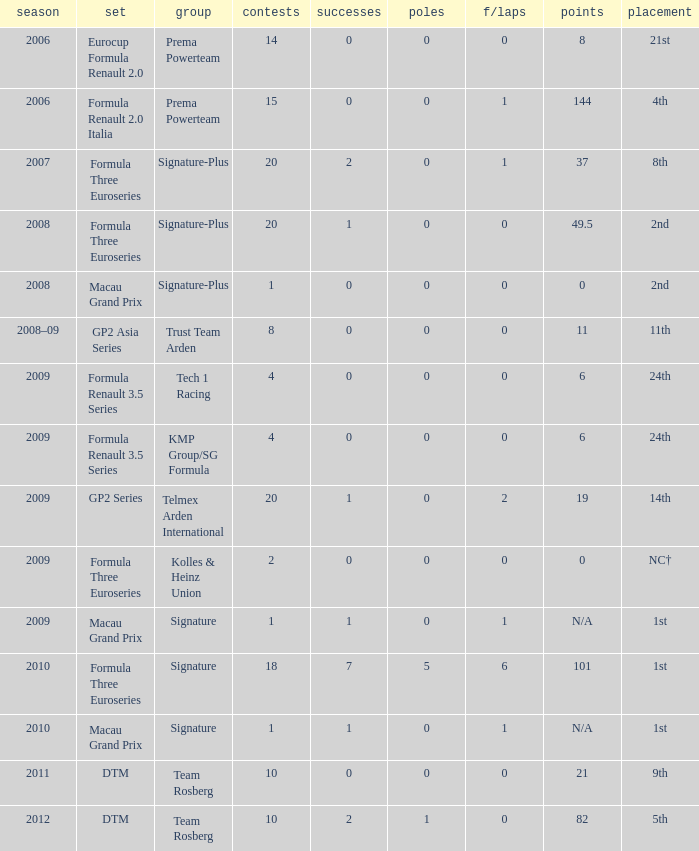How many poles are there in the 2009 season with 2 races and more than 0 F/Laps? 0.0. 